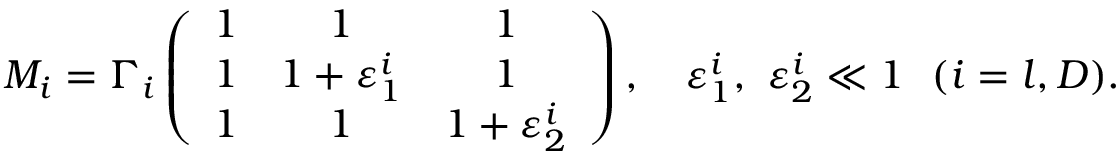Convert formula to latex. <formula><loc_0><loc_0><loc_500><loc_500>M _ { i } = \Gamma _ { i } \left ( \begin{array} { c c c } { 1 } & { 1 } & { 1 } \\ { 1 } & { { 1 + \varepsilon _ { 1 } ^ { i } } } & { 1 } \\ { 1 } & { 1 } & { { 1 + \varepsilon _ { 2 } ^ { i } } } \end{array} \right ) , \quad v a r e p s i l o n _ { 1 } ^ { i } , \ \varepsilon _ { 2 } ^ { i } \ll 1 \ \ ( i = l , D ) .</formula> 